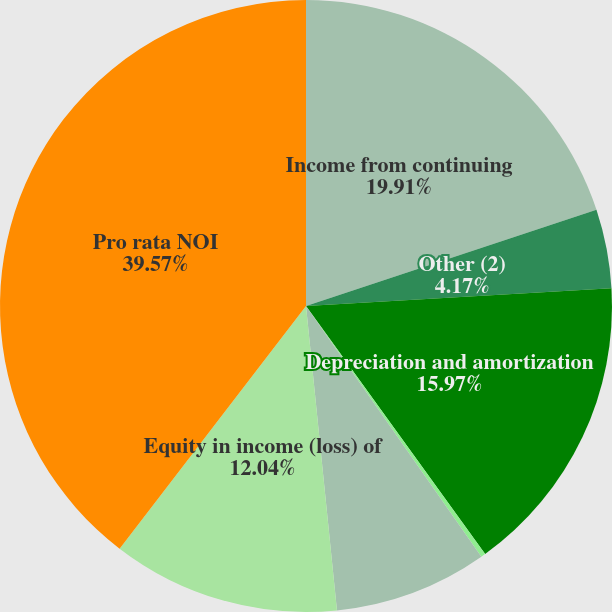Convert chart. <chart><loc_0><loc_0><loc_500><loc_500><pie_chart><fcel>Income from continuing<fcel>Other (2)<fcel>Depreciation and amortization<fcel>Other operating expense<fcel>Other expense (income)<fcel>Equity in income (loss) of<fcel>Pro rata NOI<nl><fcel>19.91%<fcel>4.17%<fcel>15.97%<fcel>0.24%<fcel>8.1%<fcel>12.04%<fcel>39.58%<nl></chart> 